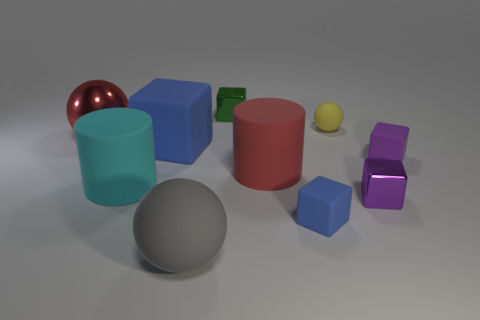Subtract all matte spheres. How many spheres are left? 1 Subtract all red cylinders. How many cylinders are left? 1 Subtract all cylinders. How many objects are left? 8 Subtract 3 blocks. How many blocks are left? 2 Subtract all tiny red metal cylinders. Subtract all small rubber spheres. How many objects are left? 9 Add 2 blue rubber cubes. How many blue rubber cubes are left? 4 Add 1 cyan objects. How many cyan objects exist? 2 Subtract 0 brown cubes. How many objects are left? 10 Subtract all purple balls. Subtract all purple cubes. How many balls are left? 3 Subtract all yellow balls. How many green blocks are left? 1 